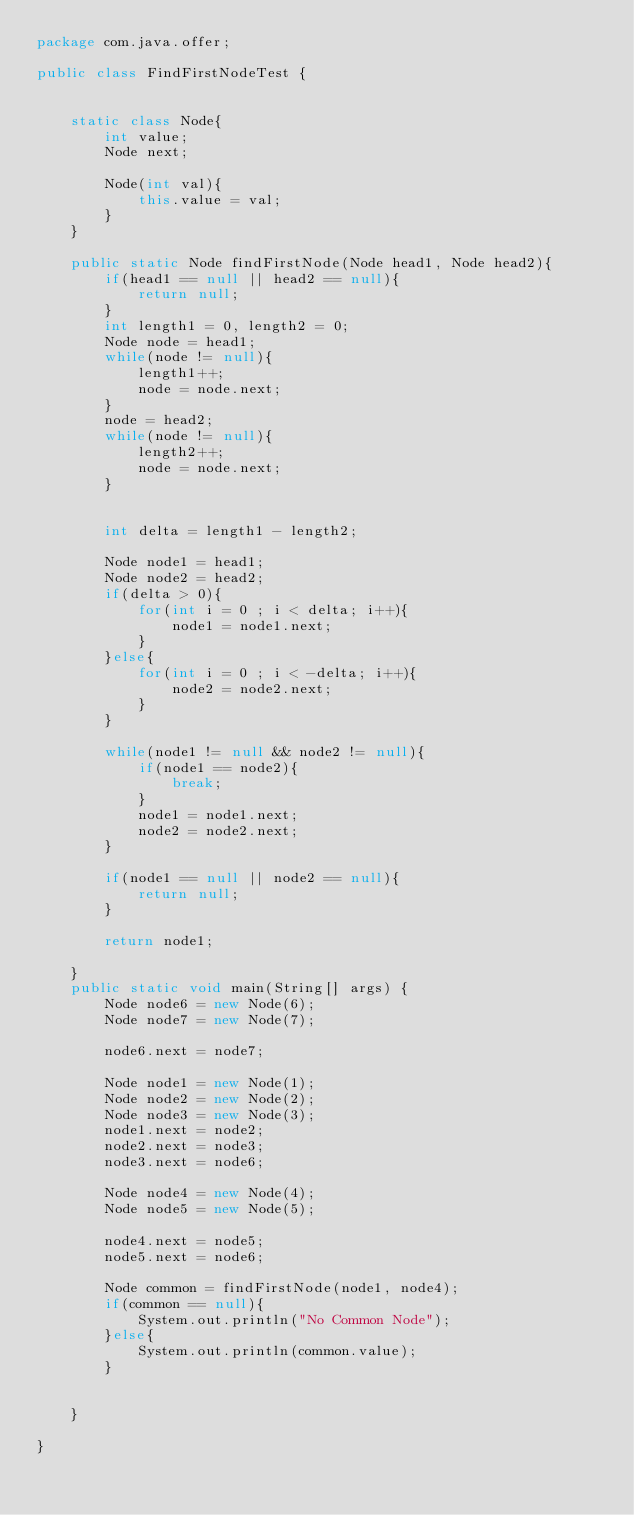Convert code to text. <code><loc_0><loc_0><loc_500><loc_500><_Java_>package com.java.offer;

public class FindFirstNodeTest {


	static class Node{
		int value;
		Node next;
		
		Node(int val){
			this.value = val;
		}
	}

	public static Node findFirstNode(Node head1, Node head2){
		if(head1 == null || head2 == null){
			return null;
		}
		int length1 = 0, length2 = 0;
		Node node = head1;
		while(node != null){
			length1++;
			node = node.next;
		}
		node = head2;
		while(node != null){
			length2++;
			node = node.next;
		}
		
		
		int delta = length1 - length2;
		
		Node node1 = head1;
		Node node2 = head2;
		if(delta > 0){
			for(int i = 0 ; i < delta; i++){
				node1 = node1.next;
			}
		}else{
			for(int i = 0 ; i < -delta; i++){
				node2 = node2.next;
			}
		}
		
		while(node1 != null && node2 != null){
			if(node1 == node2){
				break;
			}
			node1 = node1.next;
			node2 = node2.next;
		}
		
		if(node1 == null || node2 == null){
			return null;
		}
		
		return node1;
		
	}
	public static void main(String[] args) {
		Node node6 = new Node(6);
		Node node7 = new Node(7);
		
		node6.next = node7;
		
		Node node1 = new Node(1);
		Node node2 = new Node(2);
		Node node3 = new Node(3);
		node1.next = node2;
		node2.next = node3;
		node3.next = node6;
		
		Node node4 = new Node(4);
		Node node5 = new Node(5);
		
		node4.next = node5;
		node5.next = node6;
		
		Node common = findFirstNode(node1, node4);
		if(common == null){
			System.out.println("No Common Node");
		}else{
			System.out.println(common.value);
		}
		

	}

}
</code> 